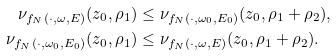Convert formula to latex. <formula><loc_0><loc_0><loc_500><loc_500>\nu _ { f _ { N } ( \cdot , \omega , E ) } ( z _ { 0 } , \rho _ { 1 } ) & \leq \nu _ { f _ { N } ( \cdot , \omega _ { 0 } , E _ { 0 } ) } ( z _ { 0 } , \rho _ { 1 } + \rho _ { 2 } ) , \\ \nu _ { f _ { N } ( \cdot , \omega _ { 0 } , E _ { 0 } ) } ( z _ { 0 } , \rho _ { 1 } ) & \leq \nu _ { f _ { N } ( \cdot , \omega , E ) } ( z _ { 0 } , \rho _ { 1 } + \rho _ { 2 } ) .</formula> 